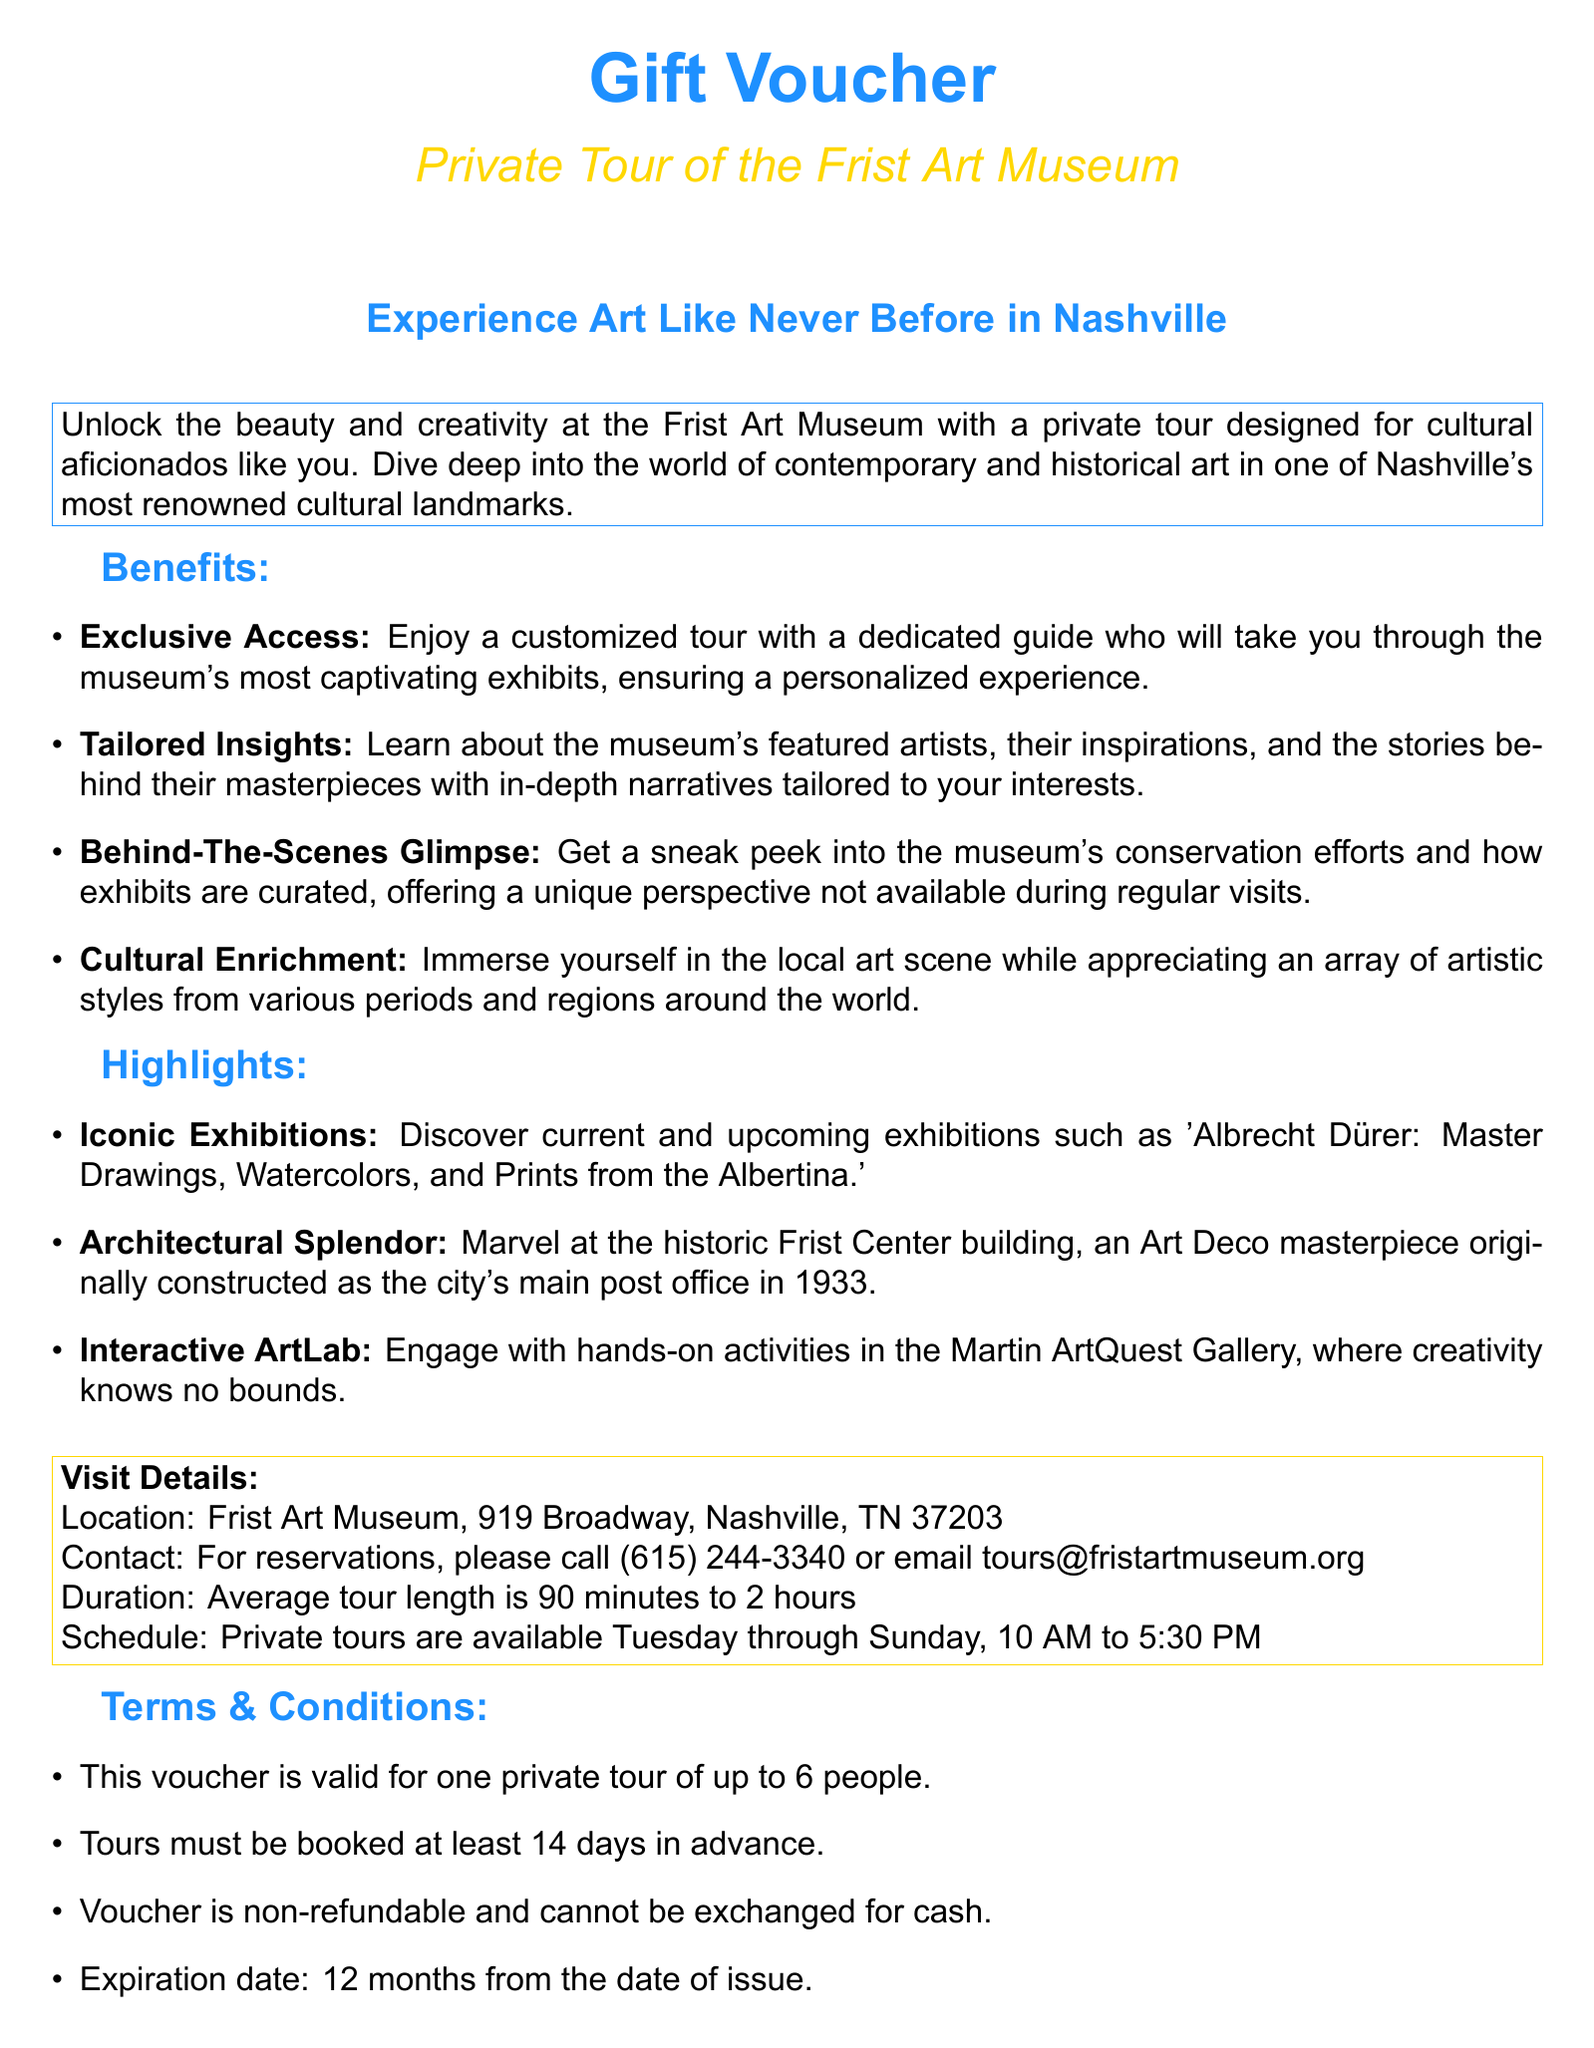What is the location of the Frist Art Museum? The location of the Frist Art Museum is clearly indicated in the document as 919 Broadway, Nashville, TN 37203.
Answer: 919 Broadway, Nashville, TN 37203 What is the maximum number of people allowed for the private tour? The document specifies that the voucher is valid for one private tour of up to 6 people.
Answer: 6 people What days are private tours available? The document states that private tours are available Tuesday through Sunday.
Answer: Tuesday through Sunday What is the average length of the tour? The document mentions that the average tour length is 90 minutes to 2 hours.
Answer: 90 minutes to 2 hours How many days in advance must tours be booked? The document requires that tours must be booked at least 14 days in advance.
Answer: 14 days What type of art does the museum feature? The document mentions that the tour offers insights into contemporary and historical art.
Answer: Contemporary and historical art What must the voucher not be exchanged for? According to the document, the voucher is non-refundable and cannot be exchanged for cash.
Answer: Cash What is the expiration duration of the voucher? The document states that the expiration date is 12 months from the date of issue.
Answer: 12 months 